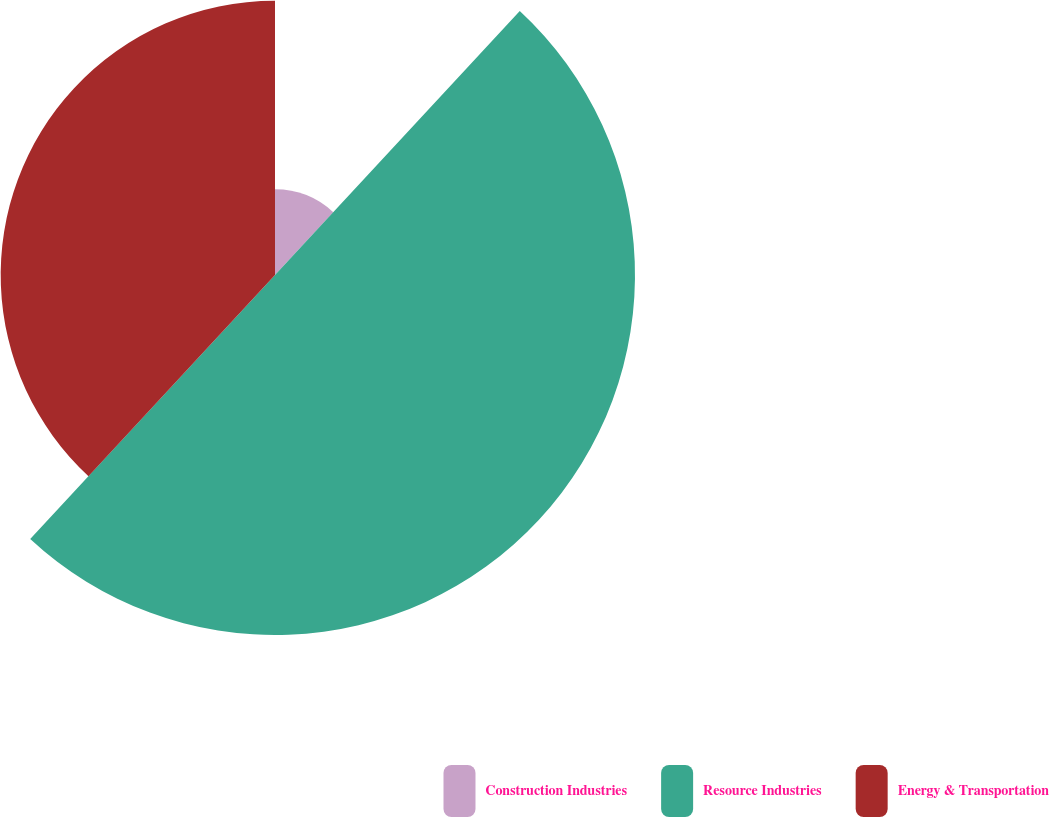Convert chart to OTSL. <chart><loc_0><loc_0><loc_500><loc_500><pie_chart><fcel>Construction Industries<fcel>Resource Industries<fcel>Energy & Transportation<nl><fcel>11.9%<fcel>50.0%<fcel>38.1%<nl></chart> 